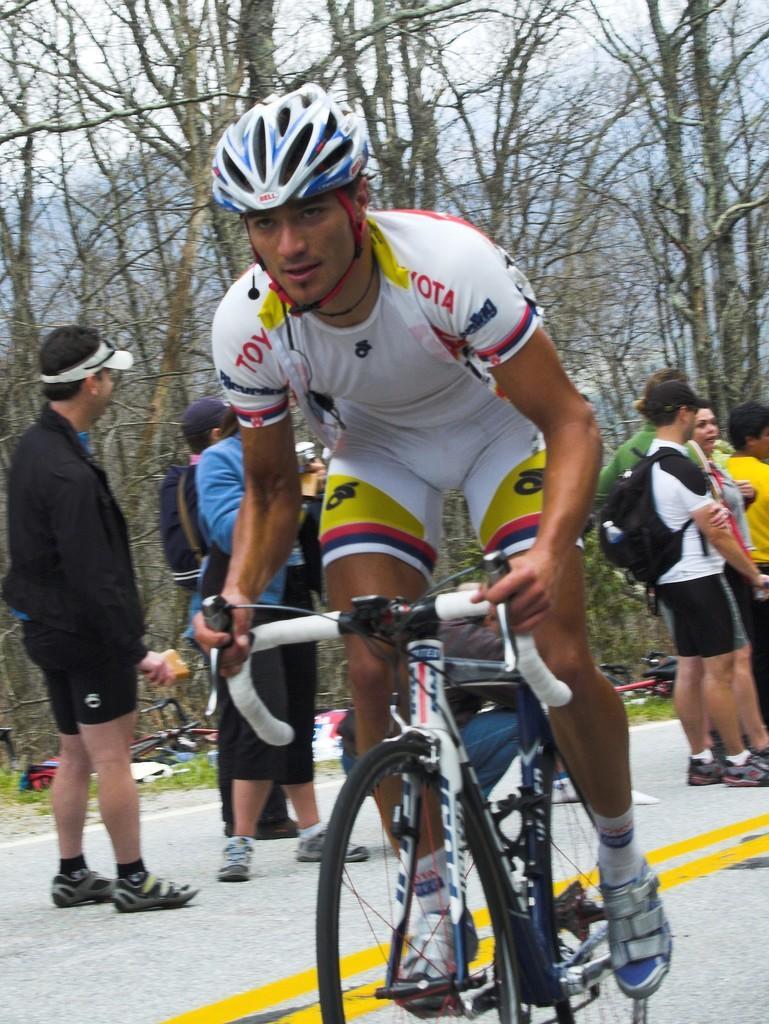Could you give a brief overview of what you see in this image? In the image we can see there is a person who is sitting on bicycle and behind there are other people who are standing and on the other side there are trees and the man is wearing helmet. 